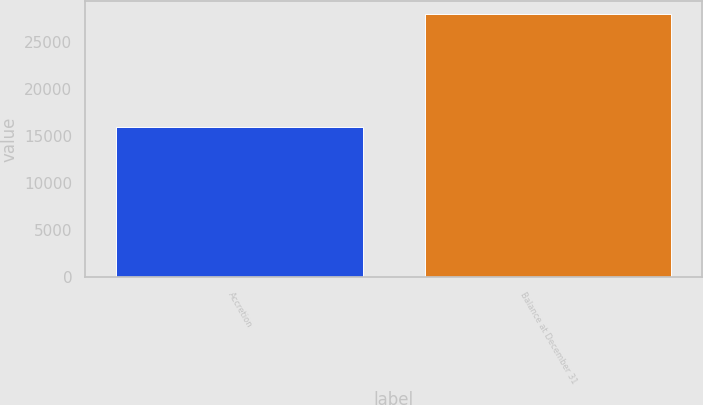<chart> <loc_0><loc_0><loc_500><loc_500><bar_chart><fcel>Accretion<fcel>Balance at December 31<nl><fcel>15931<fcel>27995<nl></chart> 